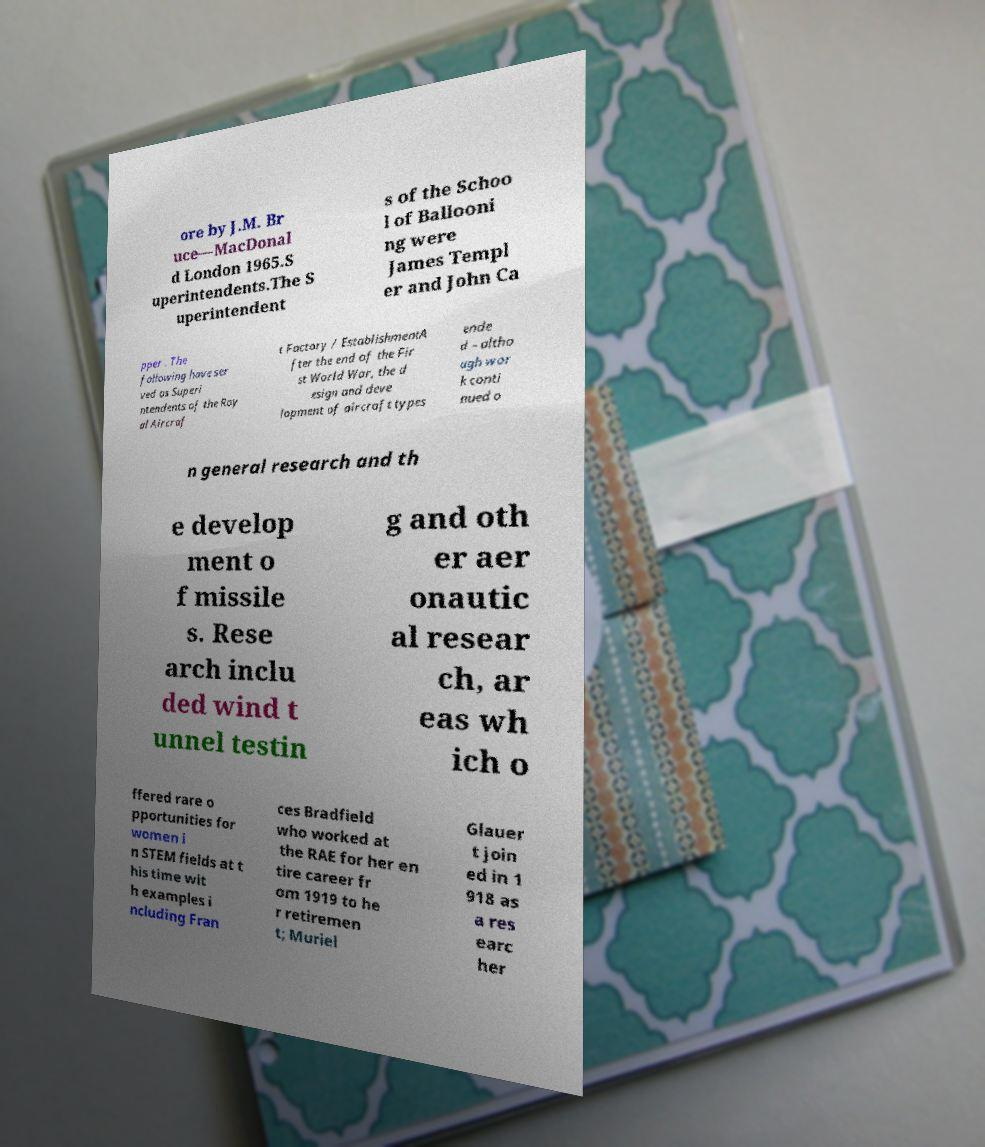Could you extract and type out the text from this image? ore by J.M. Br uce—MacDonal d London 1965.S uperintendents.The S uperintendent s of the Schoo l of Ballooni ng were James Templ er and John Ca pper . The following have ser ved as Superi ntendents of the Roy al Aircraf t Factory / EstablishmentA fter the end of the Fir st World War, the d esign and deve lopment of aircraft types ende d – altho ugh wor k conti nued o n general research and th e develop ment o f missile s. Rese arch inclu ded wind t unnel testin g and oth er aer onautic al resear ch, ar eas wh ich o ffered rare o pportunities for women i n STEM fields at t his time wit h examples i ncluding Fran ces Bradfield who worked at the RAE for her en tire career fr om 1919 to he r retiremen t; Muriel Glauer t join ed in 1 918 as a res earc her 